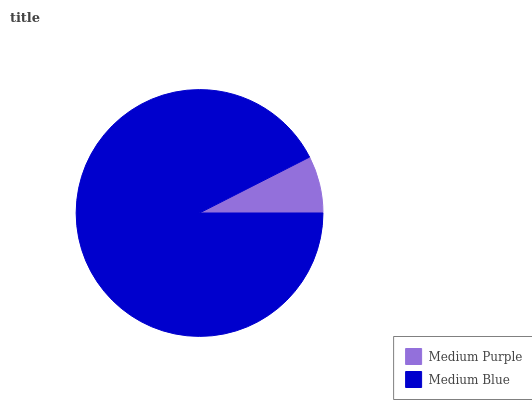Is Medium Purple the minimum?
Answer yes or no. Yes. Is Medium Blue the maximum?
Answer yes or no. Yes. Is Medium Blue the minimum?
Answer yes or no. No. Is Medium Blue greater than Medium Purple?
Answer yes or no. Yes. Is Medium Purple less than Medium Blue?
Answer yes or no. Yes. Is Medium Purple greater than Medium Blue?
Answer yes or no. No. Is Medium Blue less than Medium Purple?
Answer yes or no. No. Is Medium Blue the high median?
Answer yes or no. Yes. Is Medium Purple the low median?
Answer yes or no. Yes. Is Medium Purple the high median?
Answer yes or no. No. Is Medium Blue the low median?
Answer yes or no. No. 